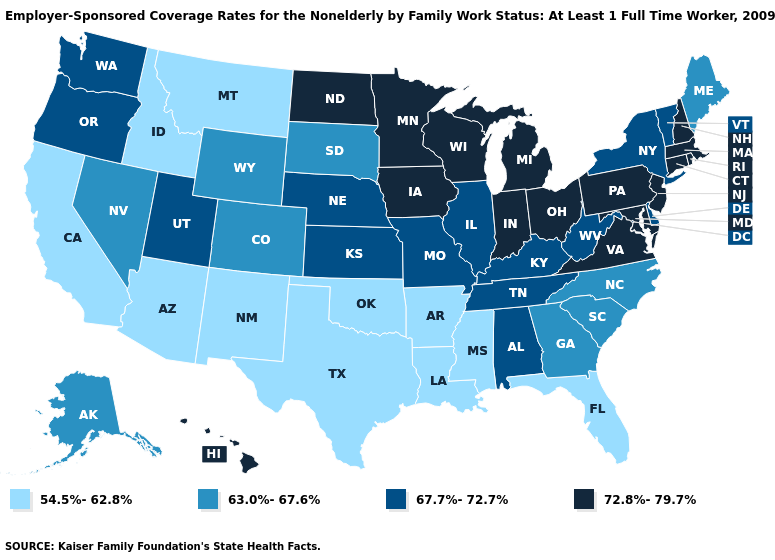Does the map have missing data?
Keep it brief. No. What is the highest value in the Northeast ?
Concise answer only. 72.8%-79.7%. Which states hav the highest value in the South?
Quick response, please. Maryland, Virginia. Among the states that border Kentucky , does West Virginia have the lowest value?
Short answer required. Yes. Which states have the highest value in the USA?
Short answer required. Connecticut, Hawaii, Indiana, Iowa, Maryland, Massachusetts, Michigan, Minnesota, New Hampshire, New Jersey, North Dakota, Ohio, Pennsylvania, Rhode Island, Virginia, Wisconsin. Name the states that have a value in the range 63.0%-67.6%?
Quick response, please. Alaska, Colorado, Georgia, Maine, Nevada, North Carolina, South Carolina, South Dakota, Wyoming. What is the value of Idaho?
Concise answer only. 54.5%-62.8%. How many symbols are there in the legend?
Short answer required. 4. Does Maine have the lowest value in the Northeast?
Short answer required. Yes. What is the highest value in the West ?
Give a very brief answer. 72.8%-79.7%. Name the states that have a value in the range 72.8%-79.7%?
Give a very brief answer. Connecticut, Hawaii, Indiana, Iowa, Maryland, Massachusetts, Michigan, Minnesota, New Hampshire, New Jersey, North Dakota, Ohio, Pennsylvania, Rhode Island, Virginia, Wisconsin. Does Michigan have the highest value in the MidWest?
Write a very short answer. Yes. Is the legend a continuous bar?
Give a very brief answer. No. Does Georgia have a lower value than Utah?
Keep it brief. Yes. Does Illinois have the highest value in the USA?
Short answer required. No. 